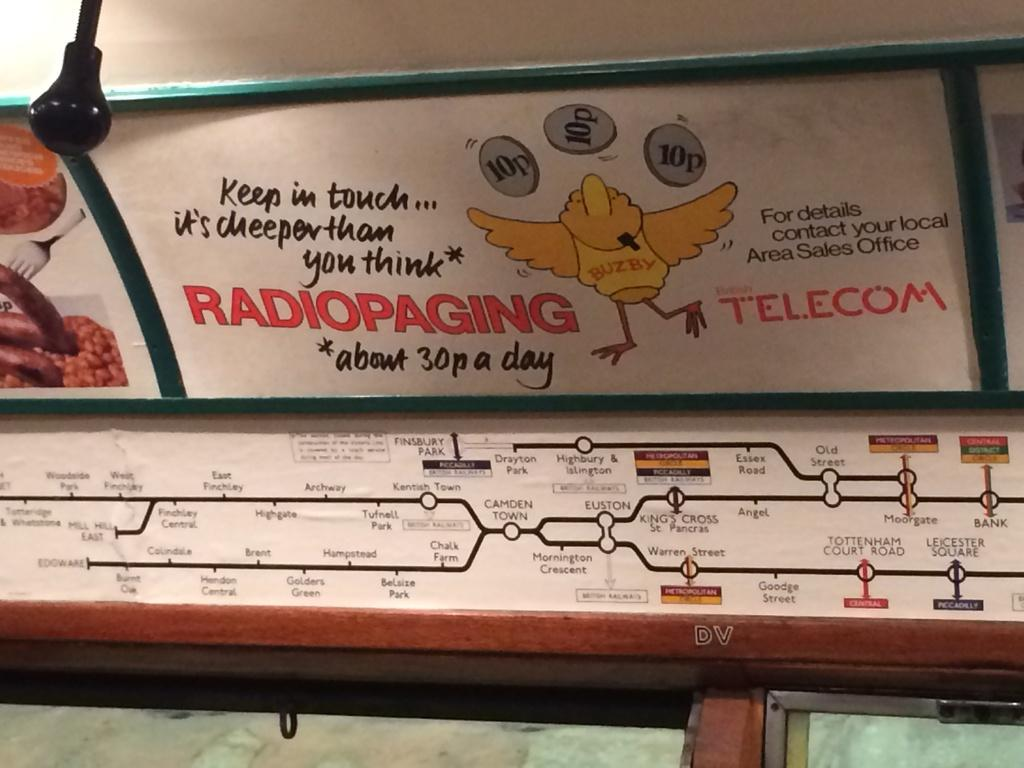<image>
Describe the image concisely. A large white sign that reads Radiopaging on top. 